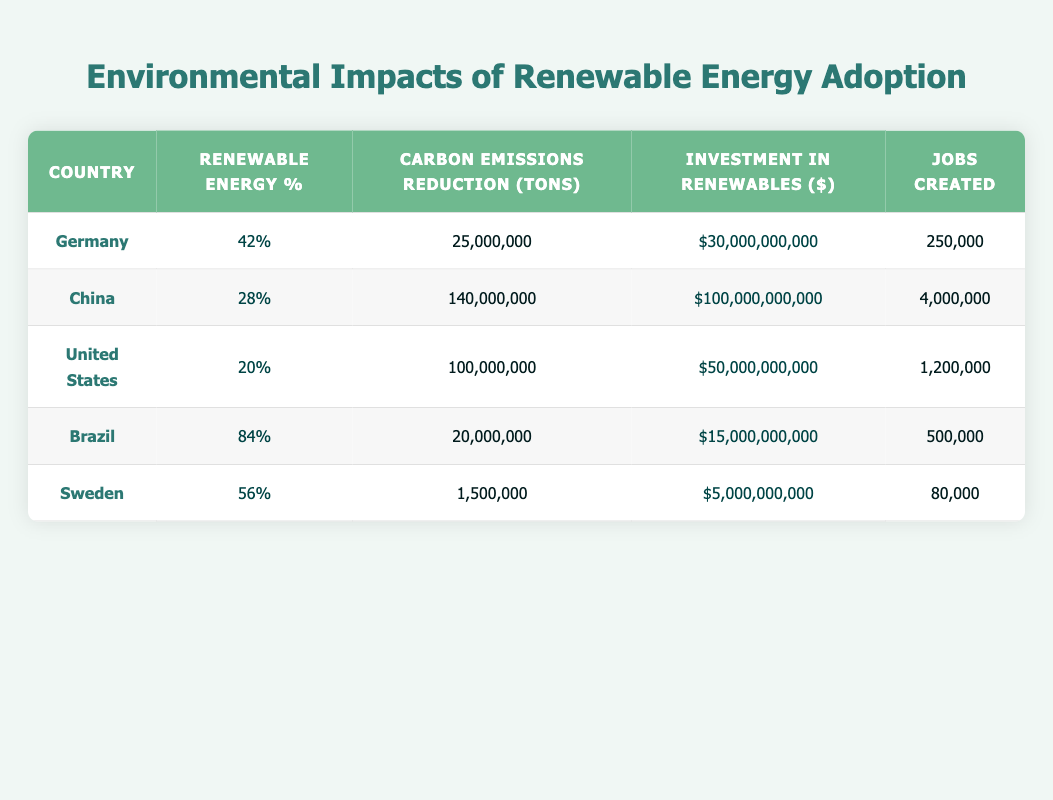What country has the highest renewable energy percentage? From the table, Brazil has a renewable energy percentage of 84%, which is higher than any other country listed.
Answer: Brazil Which country has reduced the most carbon emissions? By reviewing the carbon emissions reduction column, China has reduced 140,000,000 tons, more than any other country in the table.
Answer: China What is the total investment in renewables by Germany and Sweden? The investment in renewables for Germany is $30,000,000,000 and for Sweden is $5,000,000,000. Adding these together gives $30 billion + $5 billion = $35 billion.
Answer: $35,000,000,000 Is it true that the United States has created more jobs than Germany? The United States has created 1,200,000 jobs, whereas Germany has created 250,000 jobs. Since 1,200,000 is greater than 250,000, the statement is true.
Answer: Yes What is the average number of jobs created across all countries listed? The number of jobs created is: 250,000 (Germany) + 4,000,000 (China) + 1,200,000 (United States) + 500,000 (Brazil) + 80,000 (Sweden) = 6,030,000. There are 5 countries, so the average is 6,030,000 / 5 = 1,206,000.
Answer: 1,206,000 